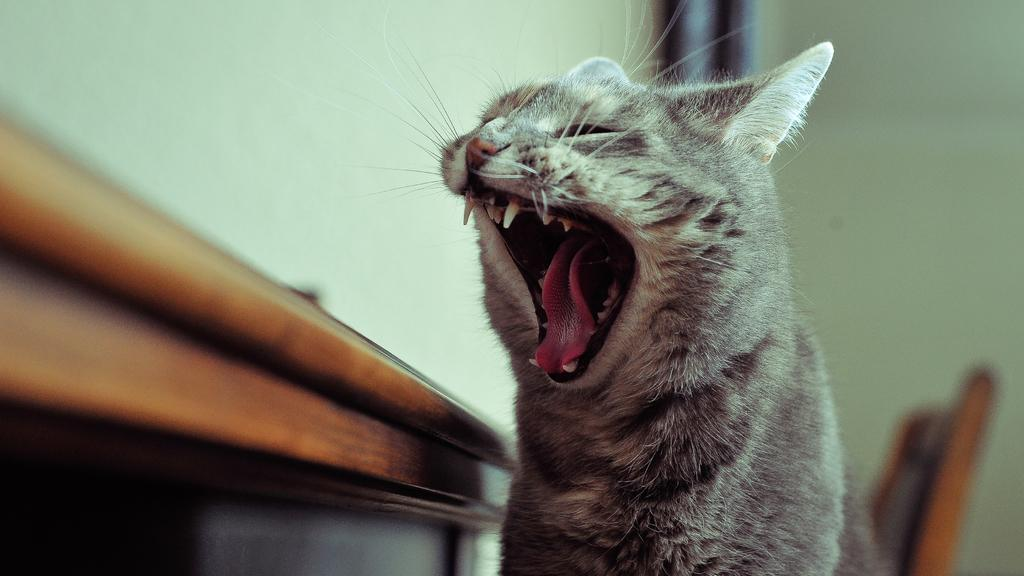What type of animal is in the image? There is a cat in the image. What is located beside the cat? There is a table beside the cat. What piece of furniture is on the right side of the image? There is a chair on the right side of the image. What can be seen in the background of the image? There is a wall in the background of the image. Can you see any hills or bushes in the image? There are no hills or bushes visible in the image; it primarily features a cat, table, chair, and wall. 